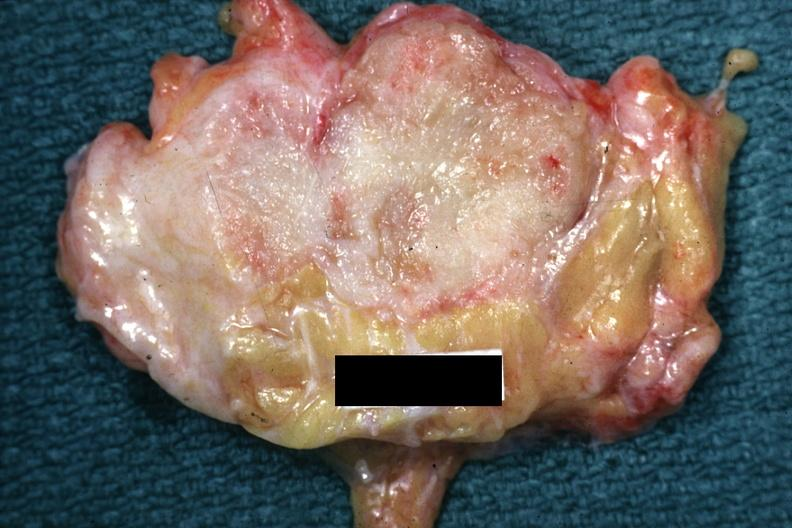what does this image show?
Answer the question using a single word or phrase. Good example of a breast carcinoma 